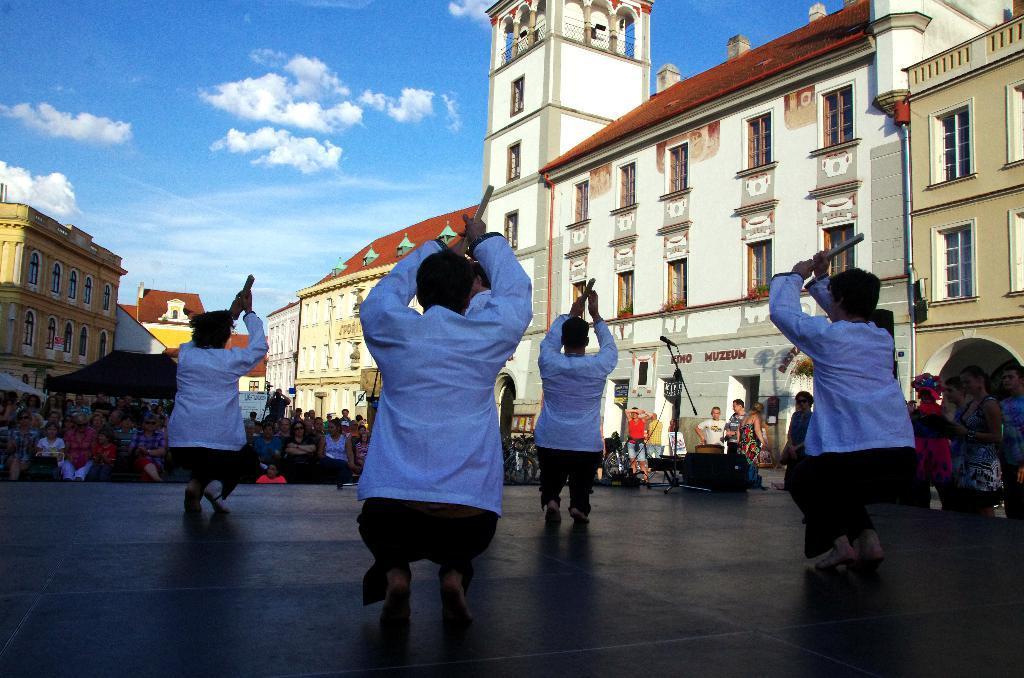Could you give a brief overview of what you see in this image? In this image in the front there are persons performing on the stage and there is a mic and there is an object which is black in colour. In the background there are persons sitting and standing, there are buildings and the sky is cloudy and on the right side there is some text written on the wall of the building. 